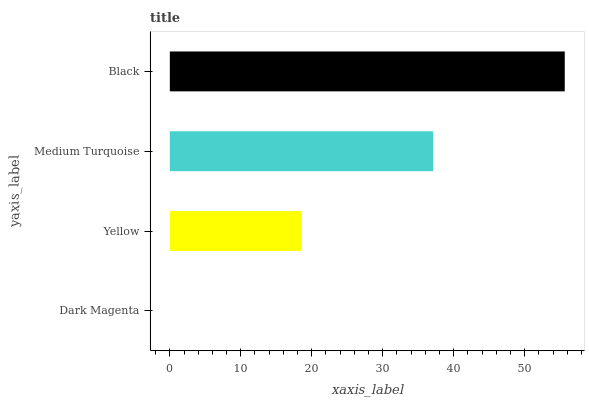Is Dark Magenta the minimum?
Answer yes or no. Yes. Is Black the maximum?
Answer yes or no. Yes. Is Yellow the minimum?
Answer yes or no. No. Is Yellow the maximum?
Answer yes or no. No. Is Yellow greater than Dark Magenta?
Answer yes or no. Yes. Is Dark Magenta less than Yellow?
Answer yes or no. Yes. Is Dark Magenta greater than Yellow?
Answer yes or no. No. Is Yellow less than Dark Magenta?
Answer yes or no. No. Is Medium Turquoise the high median?
Answer yes or no. Yes. Is Yellow the low median?
Answer yes or no. Yes. Is Black the high median?
Answer yes or no. No. Is Medium Turquoise the low median?
Answer yes or no. No. 